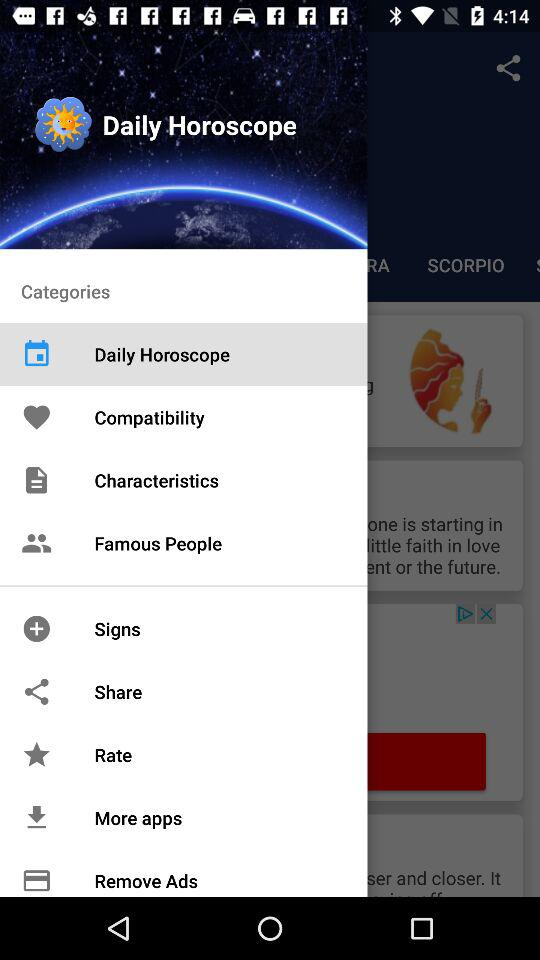How many notifications are there in "Rate"?
When the provided information is insufficient, respond with <no answer>. <no answer> 